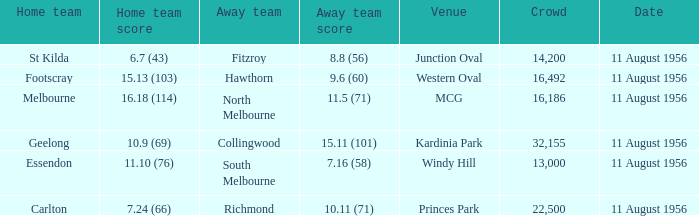What home team has a score of 16.18 (114)? Melbourne. 